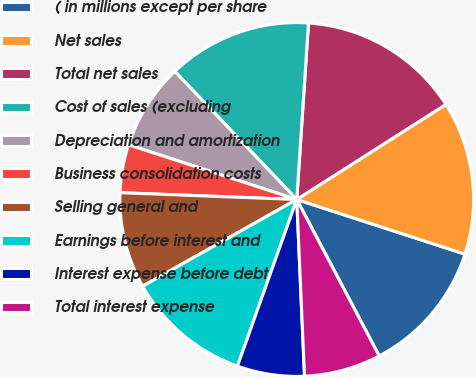Convert chart. <chart><loc_0><loc_0><loc_500><loc_500><pie_chart><fcel>( in millions except per share<fcel>Net sales<fcel>Total net sales<fcel>Cost of sales (excluding<fcel>Depreciation and amortization<fcel>Business consolidation costs<fcel>Selling general and<fcel>Earnings before interest and<fcel>Interest expense before debt<fcel>Total interest expense<nl><fcel>12.28%<fcel>14.03%<fcel>14.91%<fcel>13.16%<fcel>7.89%<fcel>4.39%<fcel>8.77%<fcel>11.4%<fcel>6.14%<fcel>7.02%<nl></chart> 